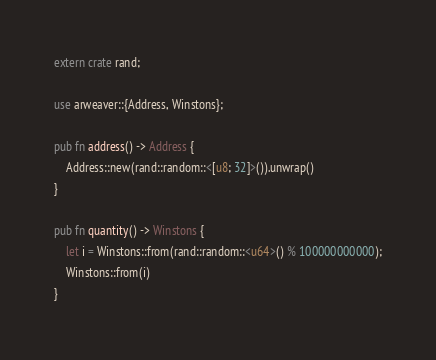<code> <loc_0><loc_0><loc_500><loc_500><_Rust_>extern crate rand;

use arweaver::{Address, Winstons};

pub fn address() -> Address {
    Address::new(rand::random::<[u8; 32]>()).unwrap()
}

pub fn quantity() -> Winstons {
    let i = Winstons::from(rand::random::<u64>() % 100000000000);
    Winstons::from(i)
}
</code> 